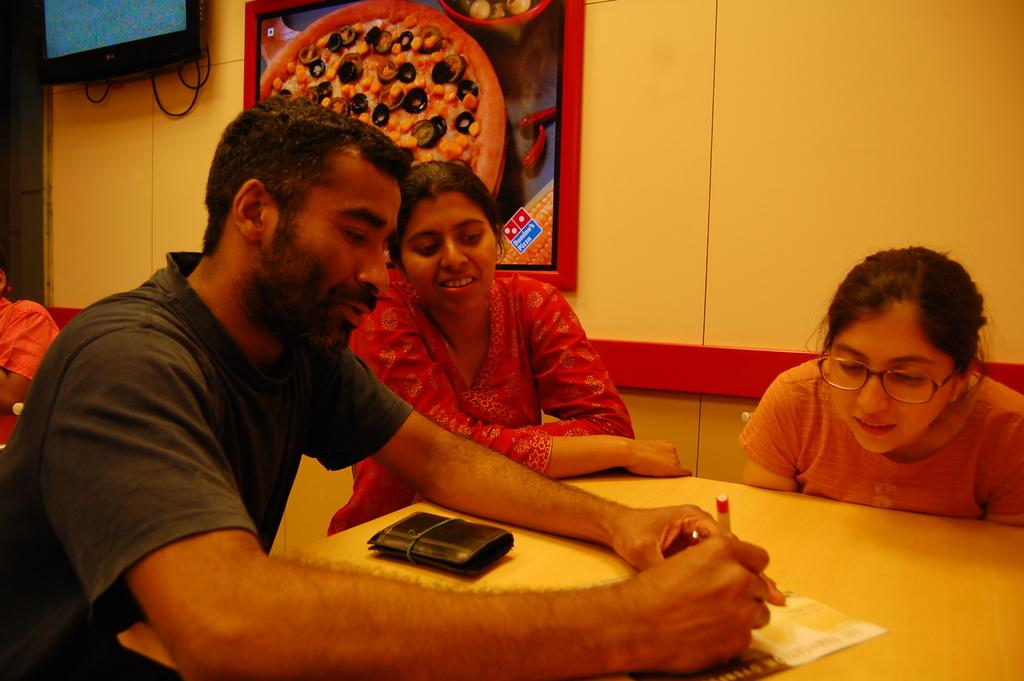How many people are seated in the image? There are two women and a man seated in the image. What is on the table in the image? There is a paper and a purse on the table. What can be seen on the wall in the image? There is a poster on the wall. What electronic device is present in the image? There is a television in the image. What type of support can be seen holding up the doll in the image? There is no doll present in the image, so there is no support for a doll. 